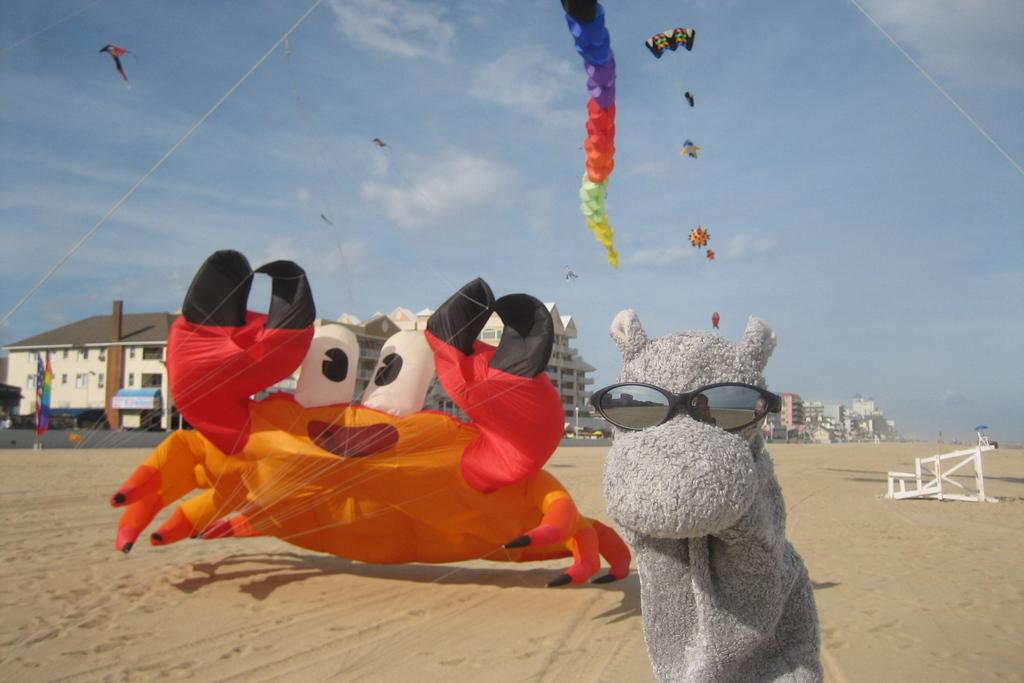What is the primary setting of the image? The primary setting of the image is the sand. What can be seen in the background of the image? There are buildings visible in the background of the image. What type of scissors can be seen in the image? There are no scissors present in the image. 